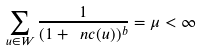<formula> <loc_0><loc_0><loc_500><loc_500>\sum _ { u \in W } \frac { 1 } { ( 1 + \ n c ( u ) ) ^ { b } } = \mu < \infty</formula> 